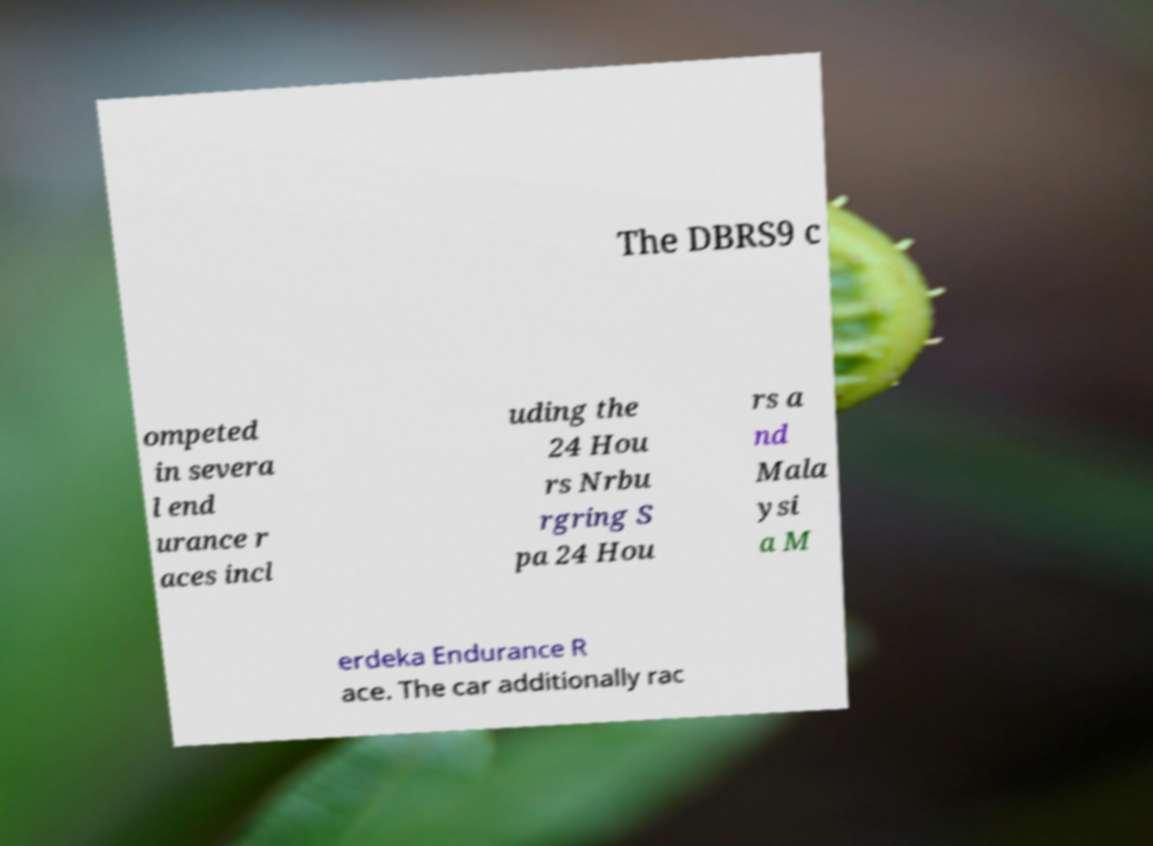What messages or text are displayed in this image? I need them in a readable, typed format. The DBRS9 c ompeted in severa l end urance r aces incl uding the 24 Hou rs Nrbu rgring S pa 24 Hou rs a nd Mala ysi a M erdeka Endurance R ace. The car additionally rac 